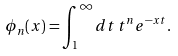<formula> <loc_0><loc_0><loc_500><loc_500>\phi _ { n } ( x ) = \int _ { 1 } ^ { \infty } d t \, t ^ { n } e ^ { - x t } .</formula> 